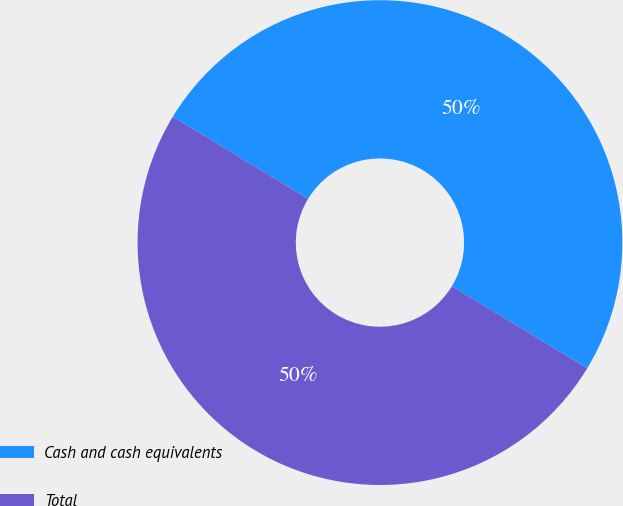Convert chart. <chart><loc_0><loc_0><loc_500><loc_500><pie_chart><fcel>Cash and cash equivalents<fcel>Total<nl><fcel>49.98%<fcel>50.02%<nl></chart> 